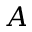<formula> <loc_0><loc_0><loc_500><loc_500>A</formula> 